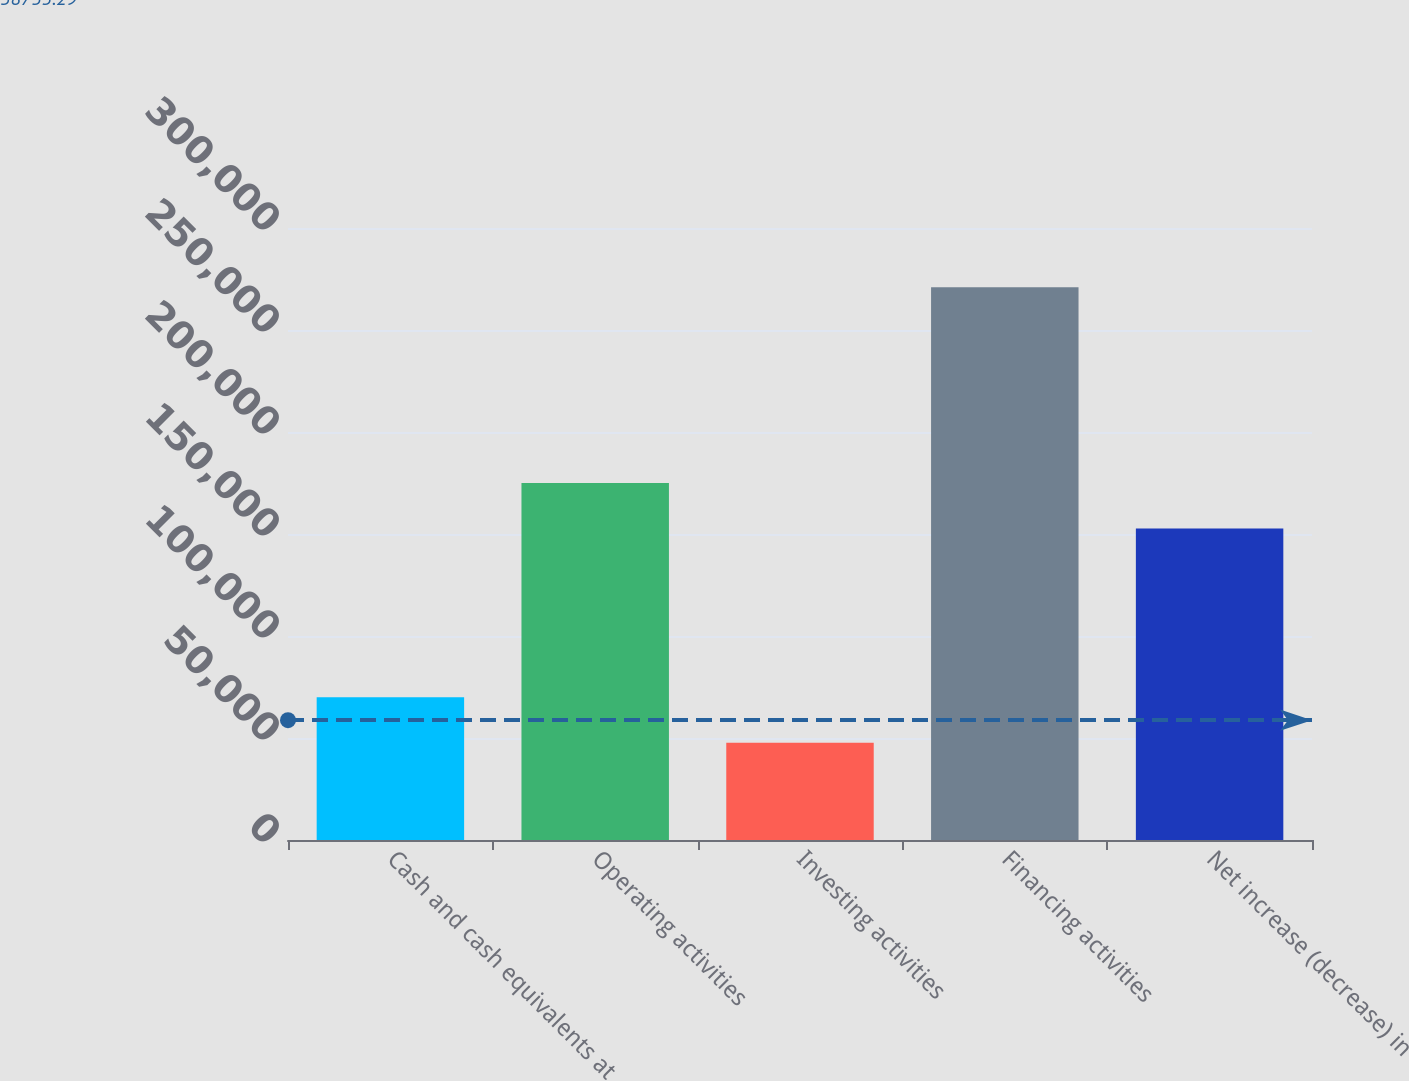Convert chart to OTSL. <chart><loc_0><loc_0><loc_500><loc_500><bar_chart><fcel>Cash and cash equivalents at<fcel>Operating activities<fcel>Investing activities<fcel>Financing activities<fcel>Net increase (decrease) in<nl><fcel>69960.6<fcel>174966<fcel>47634<fcel>270900<fcel>152639<nl></chart> 